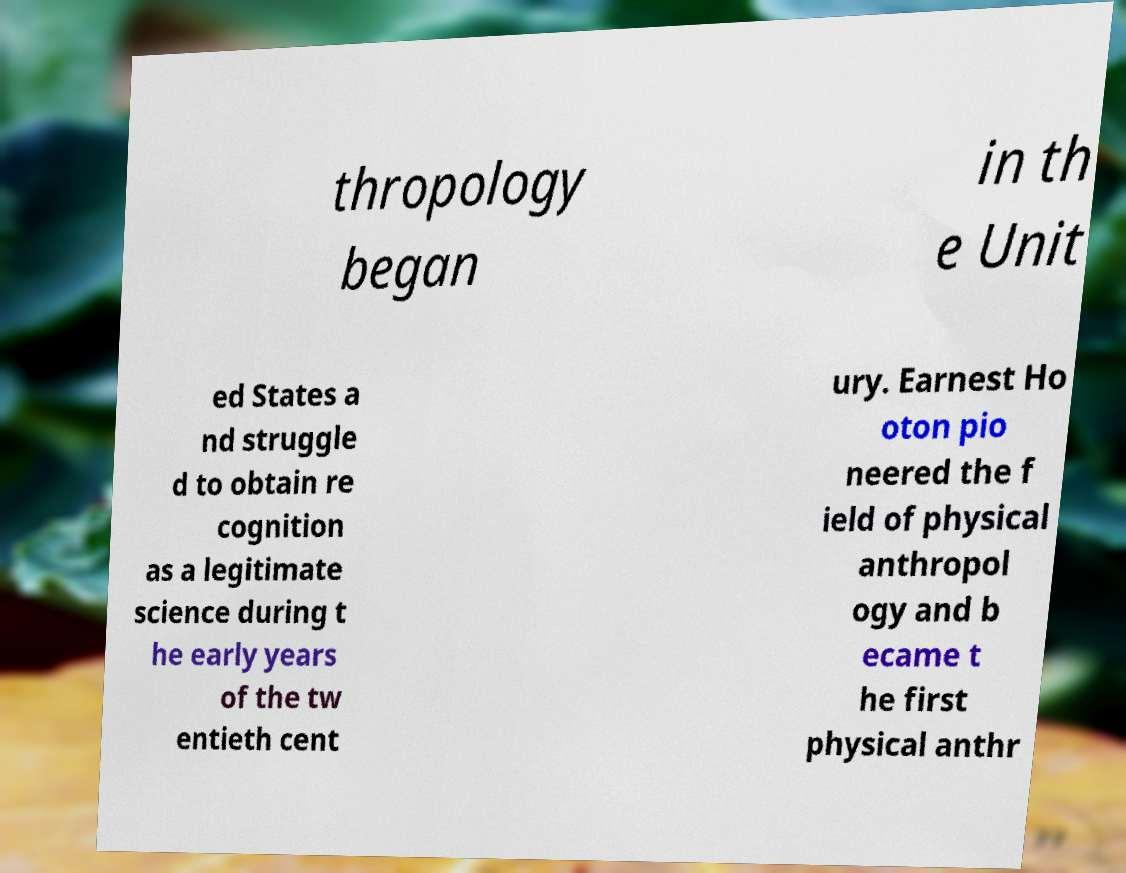Could you extract and type out the text from this image? thropology began in th e Unit ed States a nd struggle d to obtain re cognition as a legitimate science during t he early years of the tw entieth cent ury. Earnest Ho oton pio neered the f ield of physical anthropol ogy and b ecame t he first physical anthr 